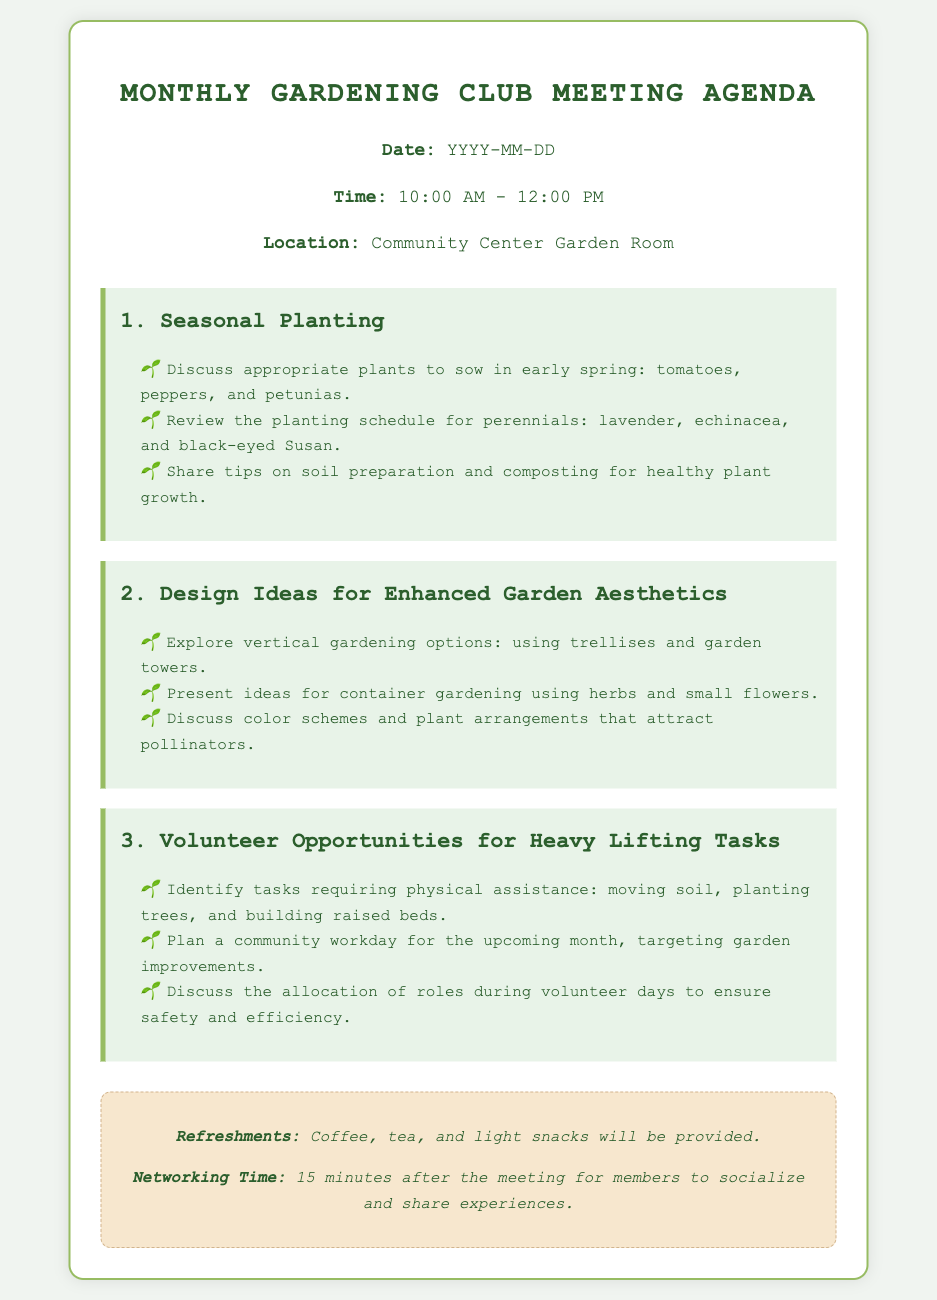What is the meeting date? The date is specified in the document as YYYY-MM-DD, indicating that it will be determined later.
Answer: YYYY-MM-DD What time does the meeting start? The meeting time is stated in the document as starting at 10:00 AM.
Answer: 10:00 AM What are the plants discussed for early spring planting? The plants mentioned for early spring are tomatoes, peppers, and petunias.
Answer: tomatoes, peppers, and petunias What design option is suggested for container gardening? The document suggests using herbs and small flowers for container gardening.
Answer: herbs and small flowers What is one task that will require physical assistance? The document lists moving soil as a task that requires physical assistance.
Answer: moving soil How long is the networking time after the meeting? Networking time is specified in the document as lasting for 15 minutes after the meeting.
Answer: 15 minutes What is one type of refreshment provided during the meeting? Coffee is mentioned as one type of refreshment that will be provided.
Answer: Coffee What is the allocated time for the meeting? The meeting is scheduled for a duration of 2 hours, from 10:00 AM to 12:00 PM.
Answer: 2 hours What is one topic discussed in the meeting? One of the topics discussed is seasonal planting, as stated in the agenda.
Answer: seasonal planting 